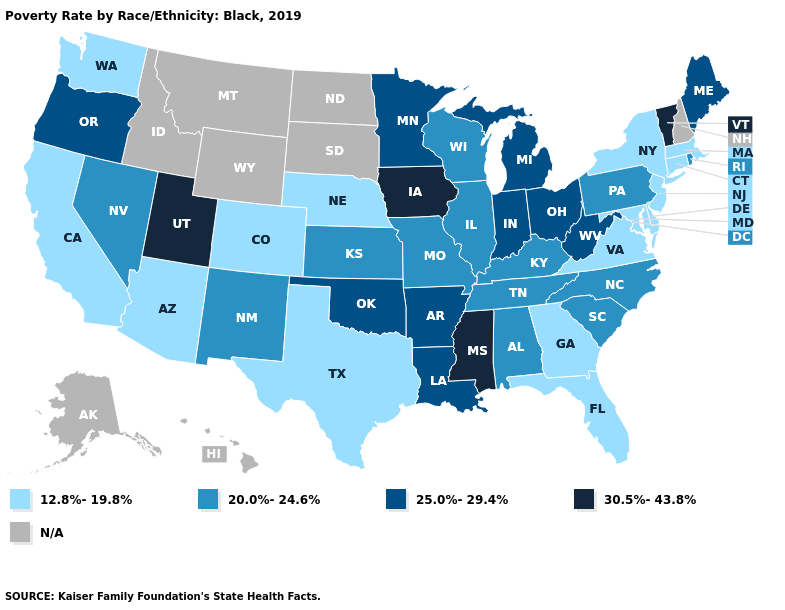Among the states that border West Virginia , which have the highest value?
Give a very brief answer. Ohio. Among the states that border Arkansas , which have the highest value?
Give a very brief answer. Mississippi. What is the lowest value in the USA?
Write a very short answer. 12.8%-19.8%. What is the value of North Carolina?
Quick response, please. 20.0%-24.6%. What is the value of Minnesota?
Write a very short answer. 25.0%-29.4%. What is the value of Minnesota?
Be succinct. 25.0%-29.4%. Which states have the highest value in the USA?
Be succinct. Iowa, Mississippi, Utah, Vermont. Among the states that border Tennessee , which have the highest value?
Keep it brief. Mississippi. Name the states that have a value in the range 25.0%-29.4%?
Short answer required. Arkansas, Indiana, Louisiana, Maine, Michigan, Minnesota, Ohio, Oklahoma, Oregon, West Virginia. Which states have the lowest value in the South?
Quick response, please. Delaware, Florida, Georgia, Maryland, Texas, Virginia. Name the states that have a value in the range 20.0%-24.6%?
Be succinct. Alabama, Illinois, Kansas, Kentucky, Missouri, Nevada, New Mexico, North Carolina, Pennsylvania, Rhode Island, South Carolina, Tennessee, Wisconsin. Does Indiana have the highest value in the MidWest?
Short answer required. No. Name the states that have a value in the range 20.0%-24.6%?
Answer briefly. Alabama, Illinois, Kansas, Kentucky, Missouri, Nevada, New Mexico, North Carolina, Pennsylvania, Rhode Island, South Carolina, Tennessee, Wisconsin. 